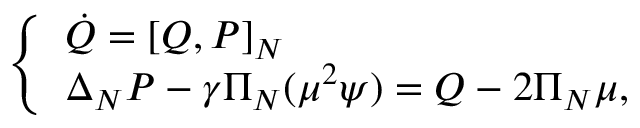Convert formula to latex. <formula><loc_0><loc_0><loc_500><loc_500>\left \{ \begin{array} { l l } { \dot { Q } = \left [ Q , P \right ] _ { N } } \\ { \Delta _ { N } P - \gamma \Pi _ { N } ( \mu ^ { 2 } \psi ) = Q - 2 \Pi _ { N } \mu , } \end{array}</formula> 